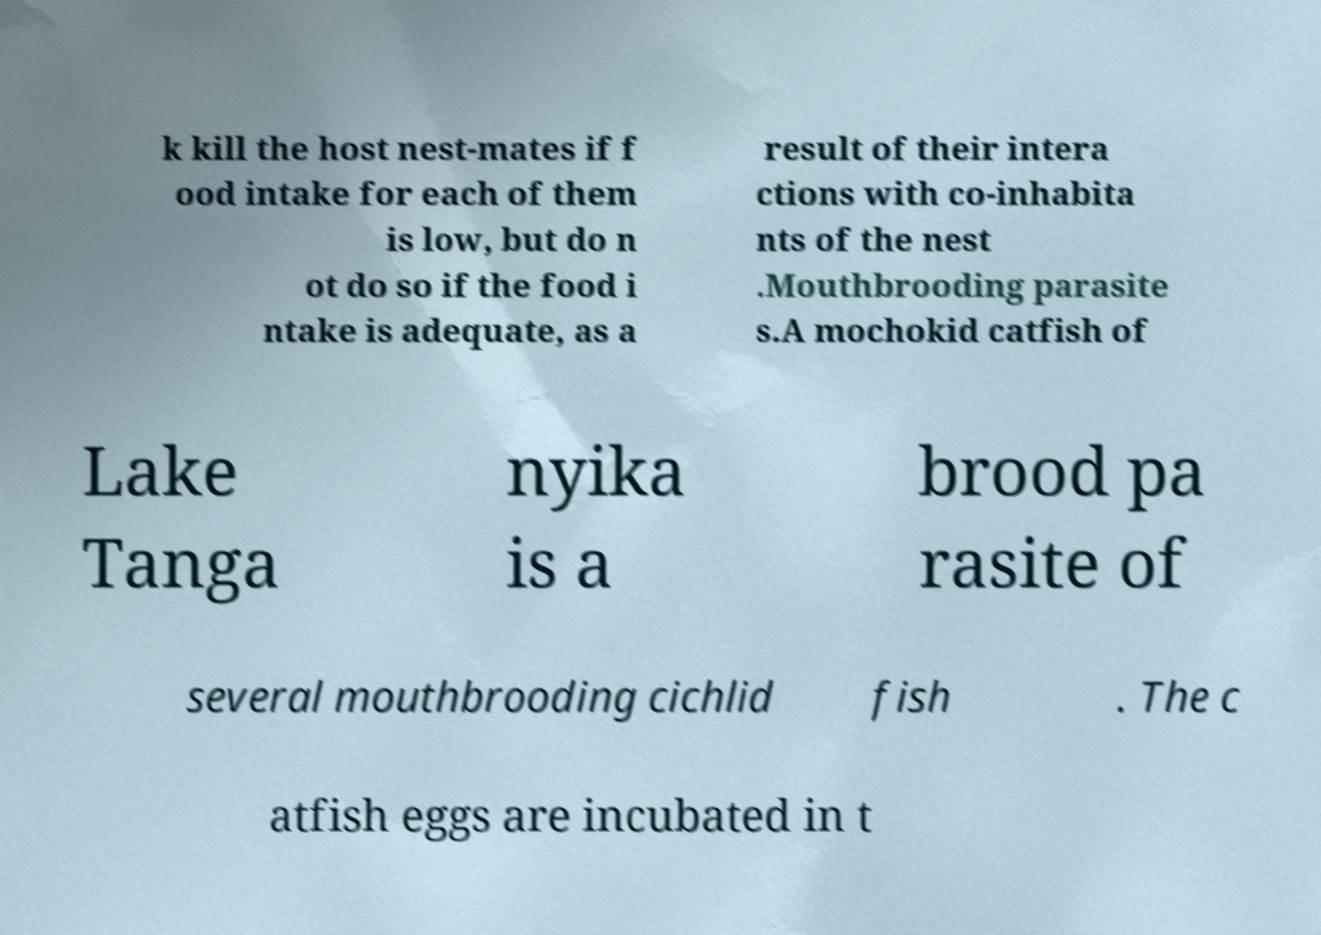For documentation purposes, I need the text within this image transcribed. Could you provide that? k kill the host nest-mates if f ood intake for each of them is low, but do n ot do so if the food i ntake is adequate, as a result of their intera ctions with co-inhabita nts of the nest .Mouthbrooding parasite s.A mochokid catfish of Lake Tanga nyika is a brood pa rasite of several mouthbrooding cichlid fish . The c atfish eggs are incubated in t 